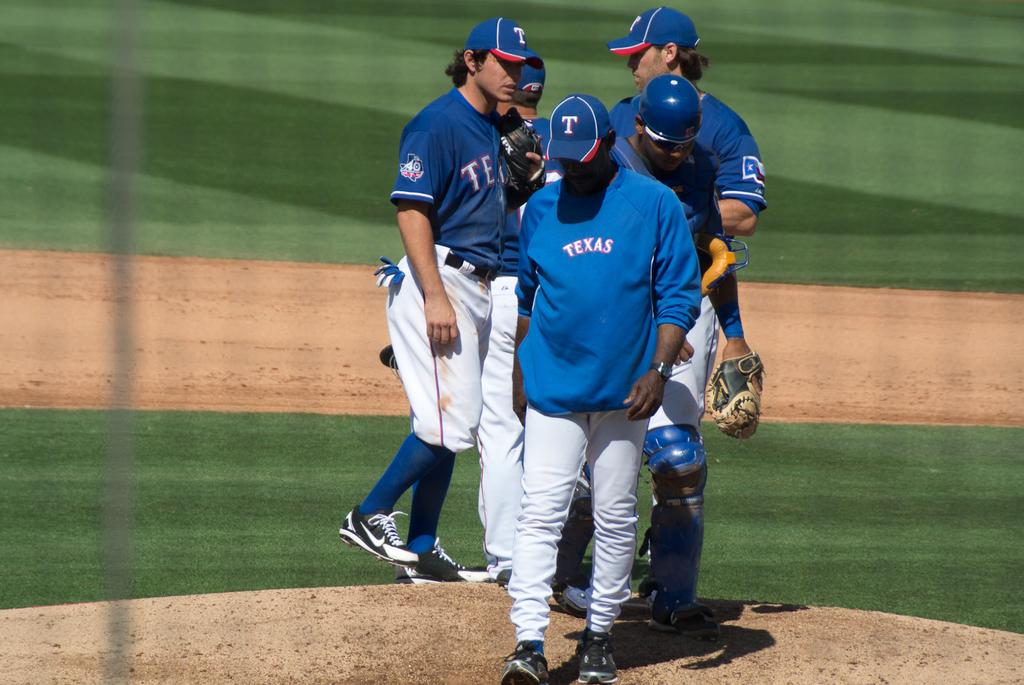<image>
Provide a brief description of the given image. A  group of five men at the pitchers mound with TEXAS shirts and jerseys 